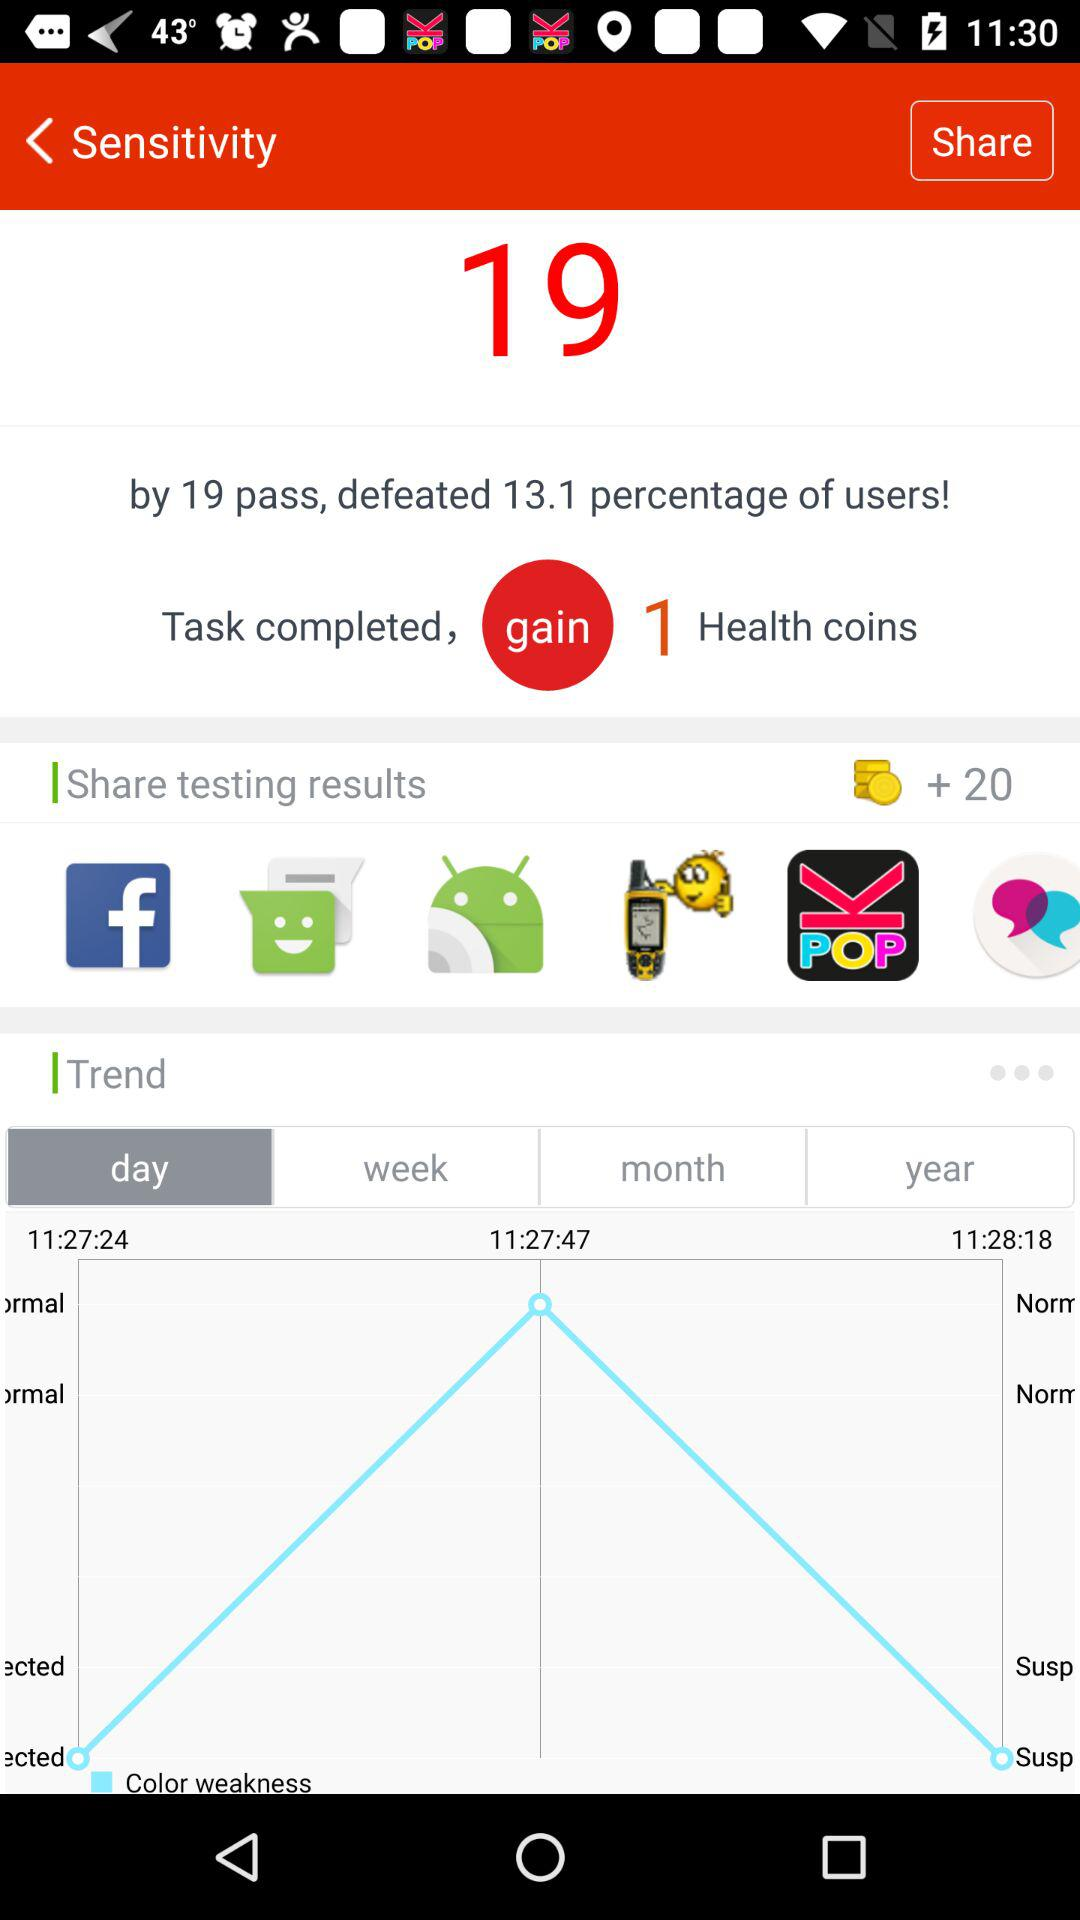How many health coins were gained? You have gained 1 heath coin. 